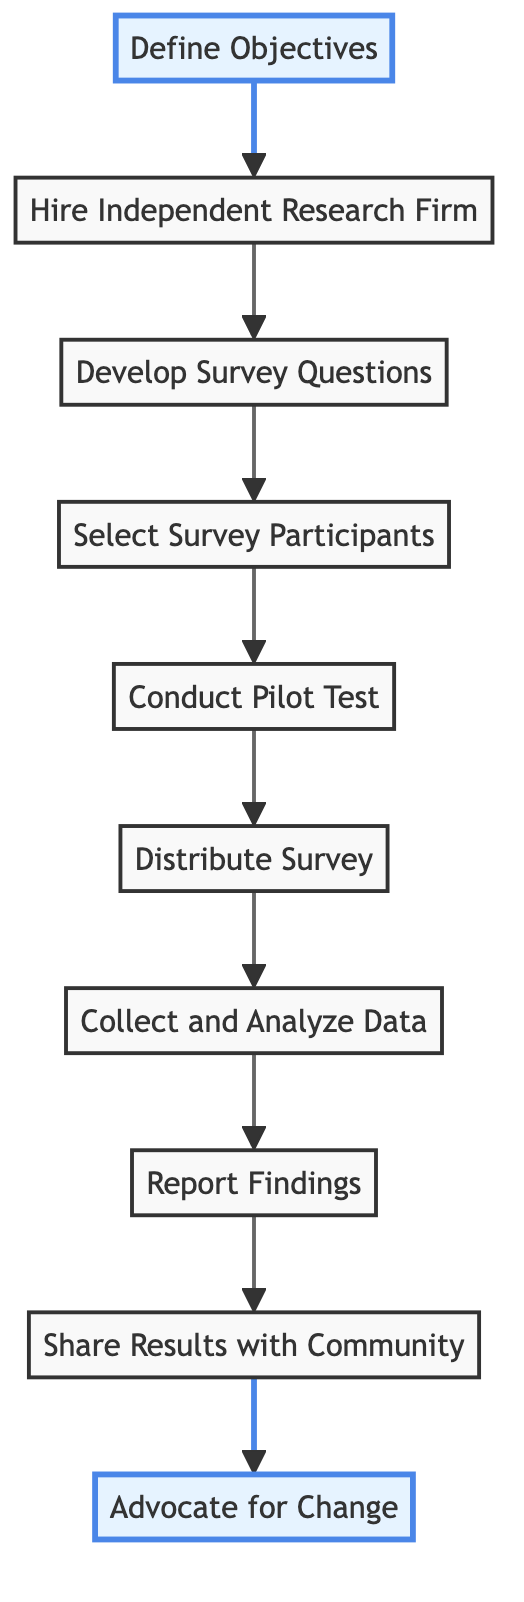What is the first step in conducting the survey? The diagram indicates that the first step is to "Define Objectives". This is clearly marked as the starting point and is the foundation for the entire process.
Answer: Define Objectives How many total steps are there in the survey process? By counting the nodes in the flowchart, we find a total of ten distinct steps leading from the start to the end of the survey process.
Answer: 10 What step follows "Develop Survey Questions"? The flowchart shows that the step following "Develop Survey Questions" is "Select Survey Participants". This establishes a clear sequence in the survey methodology.
Answer: Select Survey Participants Which steps are highlighted in the diagram? The diagram highlights "Define Objectives" and "Advocate for Change". These highlighted nodes indicate key parts of the survey process that likely require special attention.
Answer: Define Objectives, Advocate for Change What is the last step in the flow of the diagram? According to the flowchart, the last step listed is "Advocate for Change". This signifies the final action to take after completing the survey and analyzing the results.
Answer: Advocate for Change How does "Report Findings" connect to "Conduct Pilot Test"? The flowchart demonstrates that "Collect and Analyze Data" follows directly after "Conduct Pilot Test" and precedes "Report Findings". This shows the dependency of reporting on prior data collection and analysis.
Answer: Through Collect and Analyze Data What is the purpose of hiring an independent research firm? The purpose of hiring an independent research firm is to ensure unbiased results in the survey process. This is a fundamental requirement for valid research findings.
Answer: Ensure unbiased results What is the connection between "Share Results with Community" and "Report Findings"? The diagram indicates a direct sequence, where "Report Findings" precedes "Share Results with Community". This shows that results must be compiled into a report before they can be shared with community members.
Answer: Direct sequence 